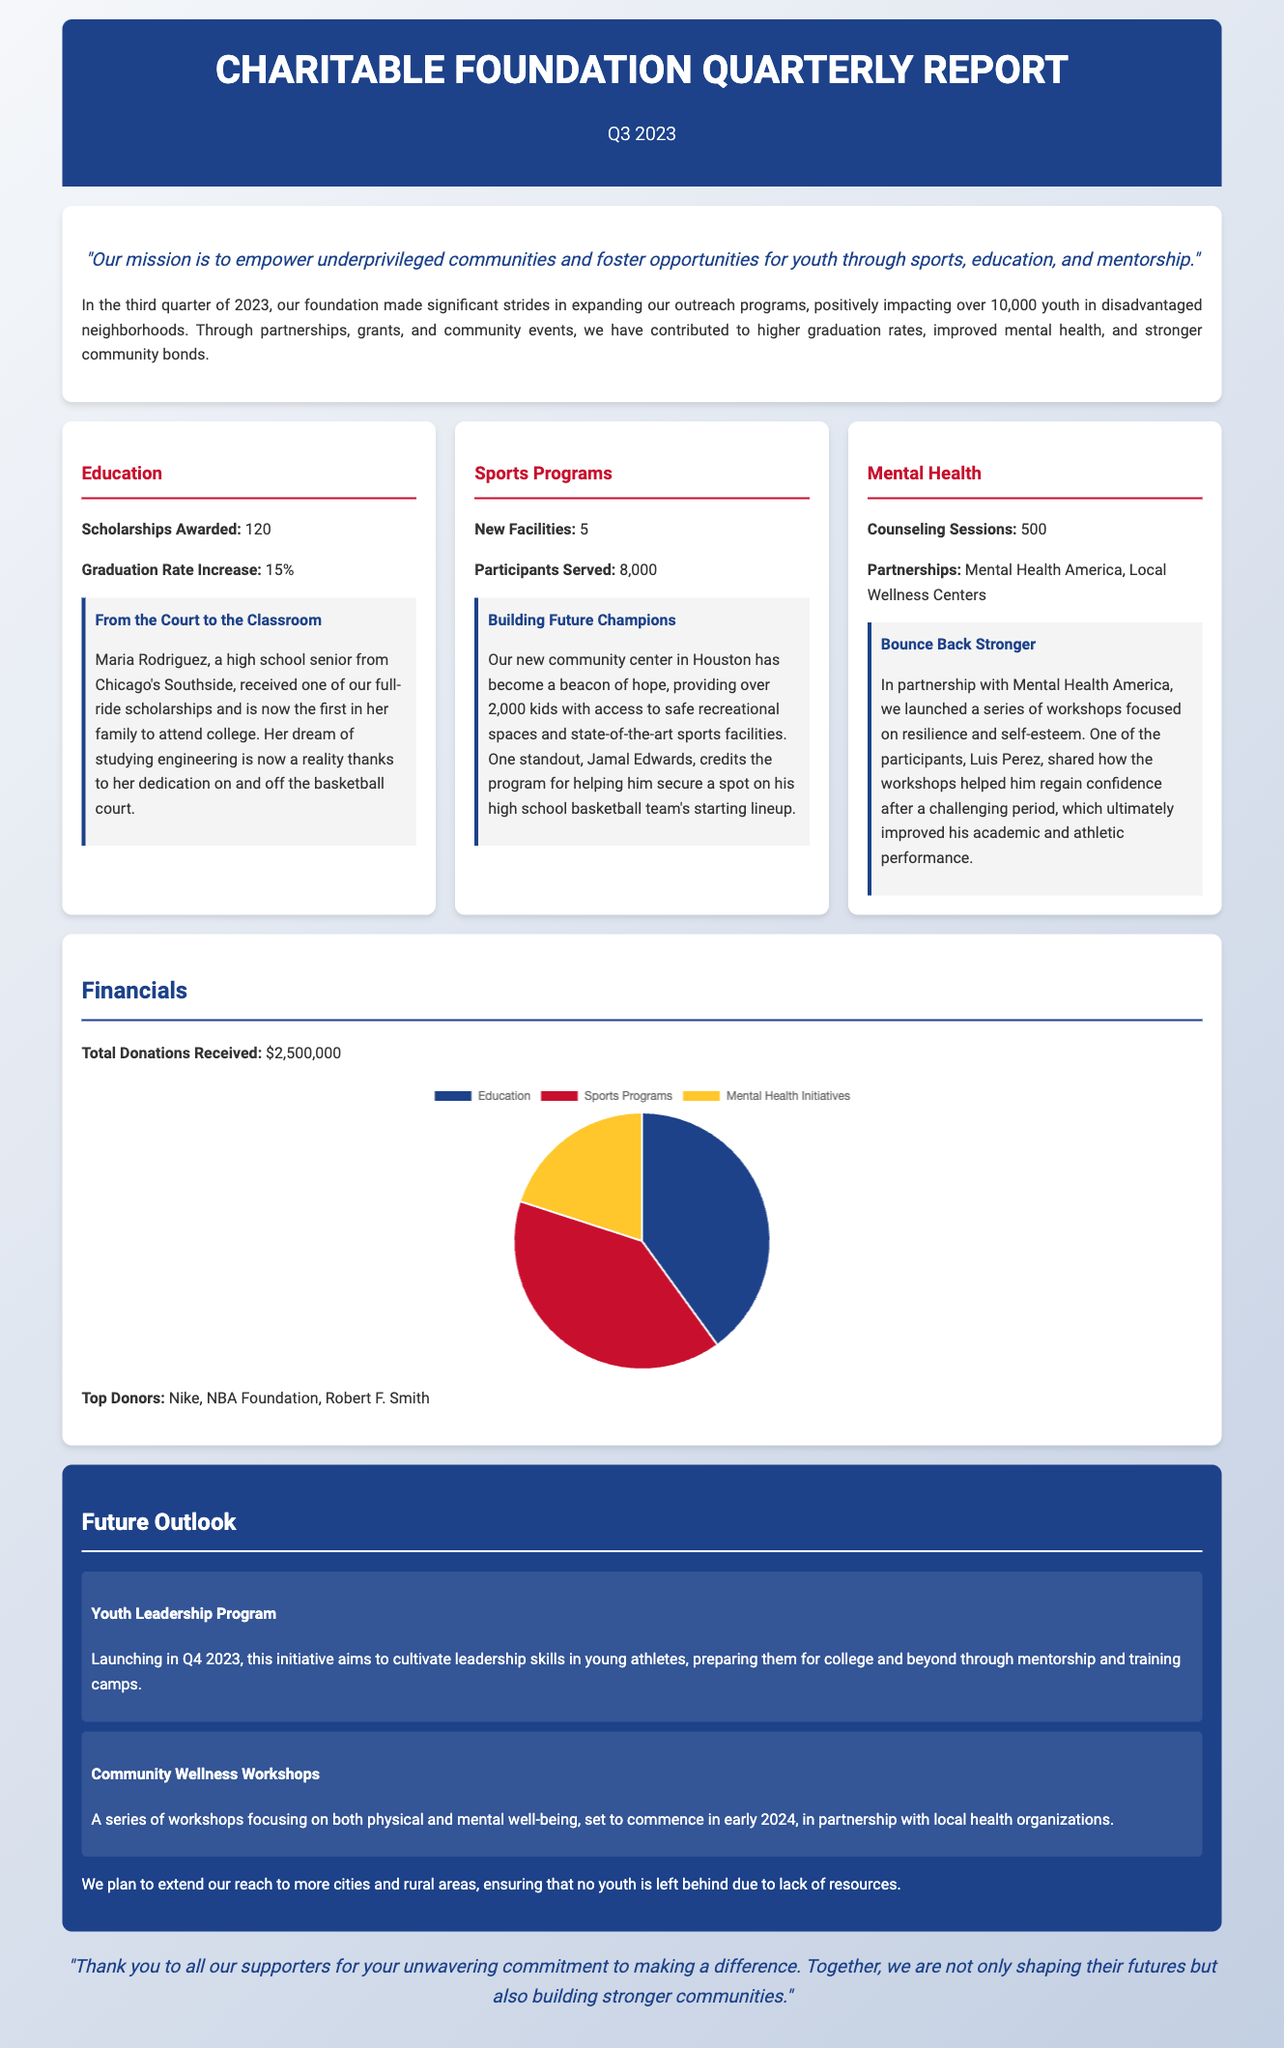What is the mission of the foundation? The mission is stated in the overview section, emphasizing empowerment through sports, education, and mentorship.
Answer: "Our mission is to empower underprivileged communities and foster opportunities for youth through sports, education, and mentorship." How many scholarships were awarded? This specific number is found in the education impact card of the report.
Answer: 120 What was the graduation rate increase? The graduation rate increase is mentioned alongside scholarships in the education impact card.
Answer: 15% How many new facilities were established? The new facilities created are listed under the sports programs impact card.
Answer: 5 Who is a highlighted success story from the education section? A specific individual is mentioned in the education impact card that showcases success due to the foundation's support.
Answer: Maria Rodriguez What is the total amount of donations received? The total donations figure is detailed in the financials section of the report.
Answer: $2,500,000 What is the title of the upcoming youth initiative? This initiative is mentioned in the future outlook section as an upcoming program.
Answer: Youth Leadership Program What was the total number of counseling sessions provided? The total number of counseling sessions is indicated in the mental health impact card.
Answer: 500 What are the top three expenditure categories? The categorized expenditures are visualized in the expenditure breakdown chart in the financials section.
Answer: Education, Sports Programs, Mental Health Initiatives 